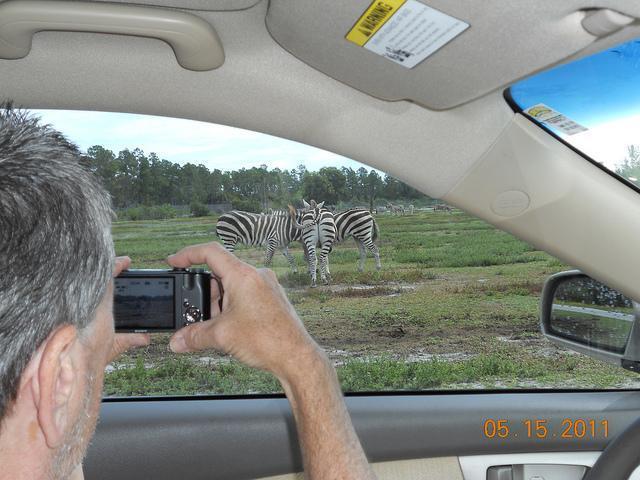How many zebras are there?
Give a very brief answer. 3. How many sinks are there?
Give a very brief answer. 0. 